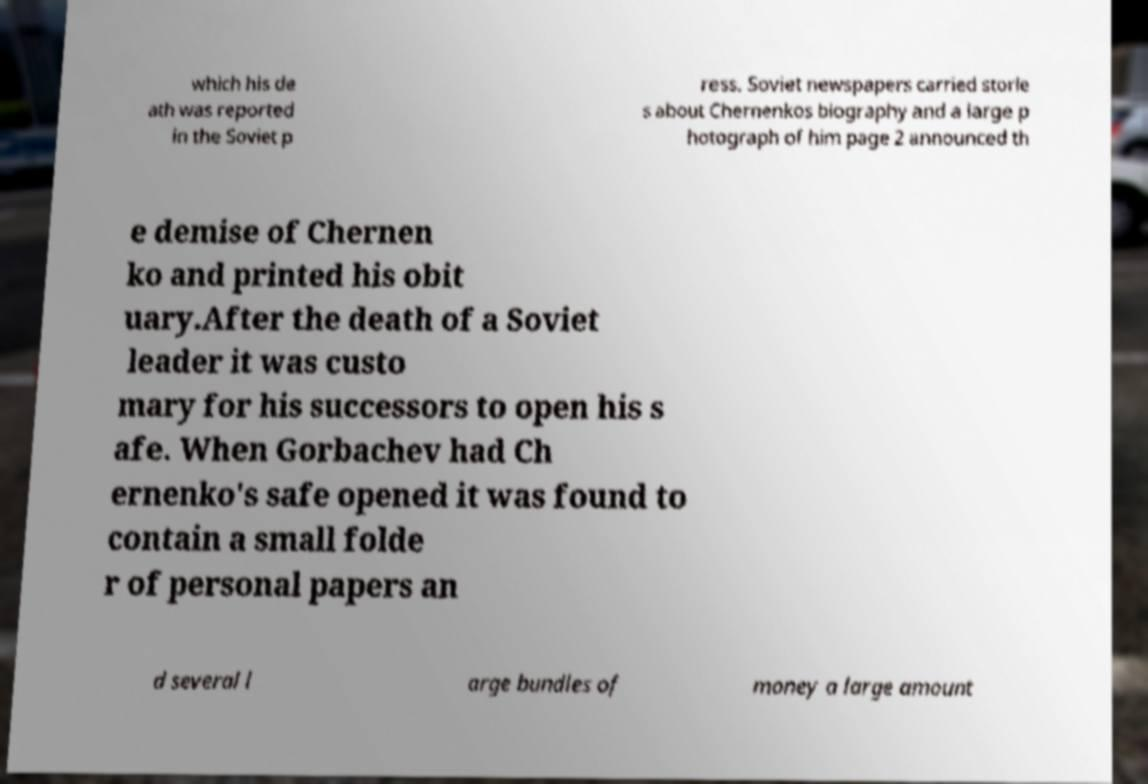I need the written content from this picture converted into text. Can you do that? which his de ath was reported in the Soviet p ress. Soviet newspapers carried storie s about Chernenkos biography and a large p hotograph of him page 2 announced th e demise of Chernen ko and printed his obit uary.After the death of a Soviet leader it was custo mary for his successors to open his s afe. When Gorbachev had Ch ernenko's safe opened it was found to contain a small folde r of personal papers an d several l arge bundles of money a large amount 